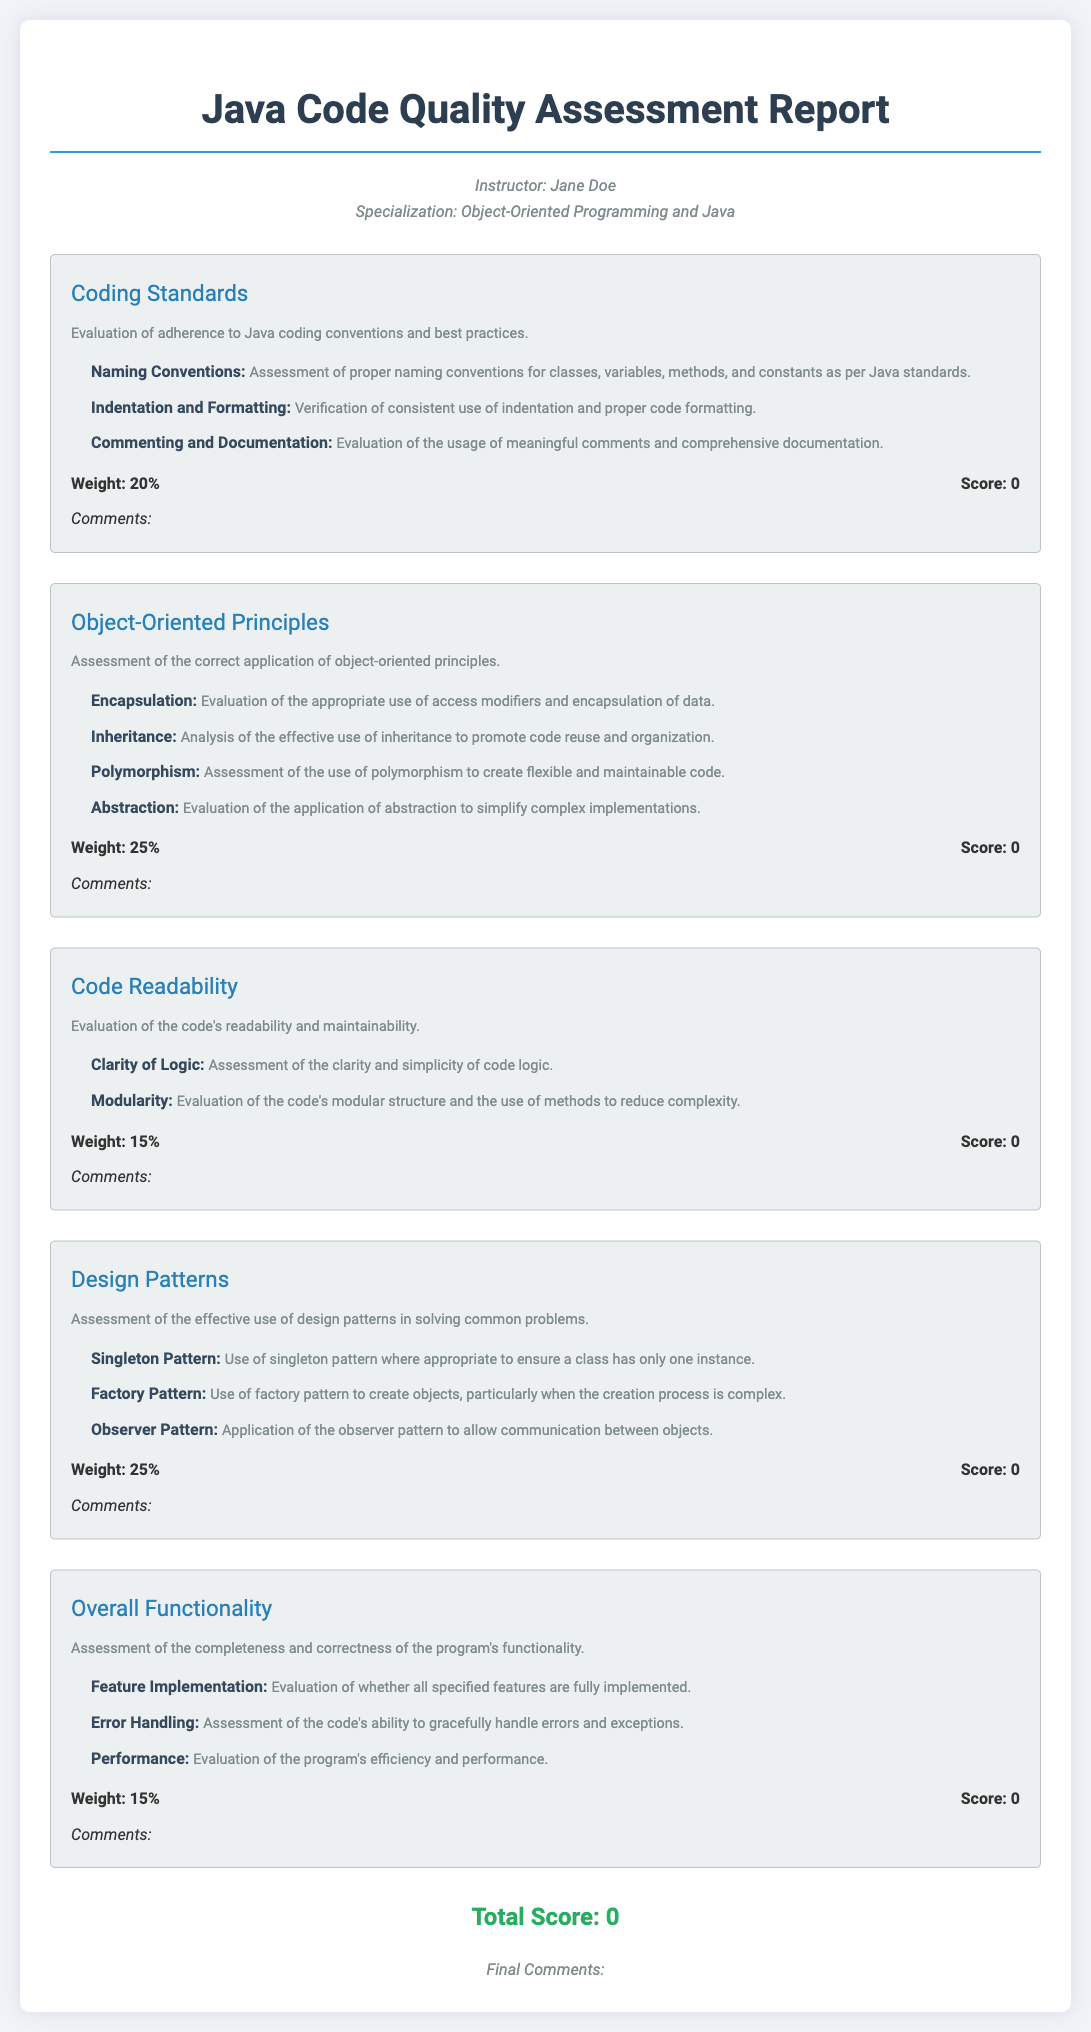What is the title of the document? The title is stated at the top of the document as the main heading.
Answer: Java Code Quality Assessment Report Who is the instructor? The instructor's name is provided in the instructor information section.
Answer: Jane Doe What is the weight of the Coding Standards section? The weight of each section is indicated next to the weight-score in their respective sections.
Answer: 20% How many sub-criteria are listed under Object-Oriented Principles? The number of sub-criteria can be counted from the list provided under that section.
Answer: 4 What is the total score listed at the bottom of the document? The total score is presented at the bottom as part of the summary of the report.
Answer: 0 Which design pattern evaluates the creation process complexity? Each design pattern is described in its respective sub-criteria, specifying its purpose.
Answer: Factory Pattern What aspect is assessed under Overall Functionality? The overall functionality includes several criteria, as outlined in its description.
Answer: Completeness and correctness What is the weight of the Code Readability section? The weight-score section directly provides this information.
Answer: 15% What does the final comments section indicate? The final comments section provides space for remaking or summarizing feedback about the overall quality and performance assessed.
Answer: Final Comments 